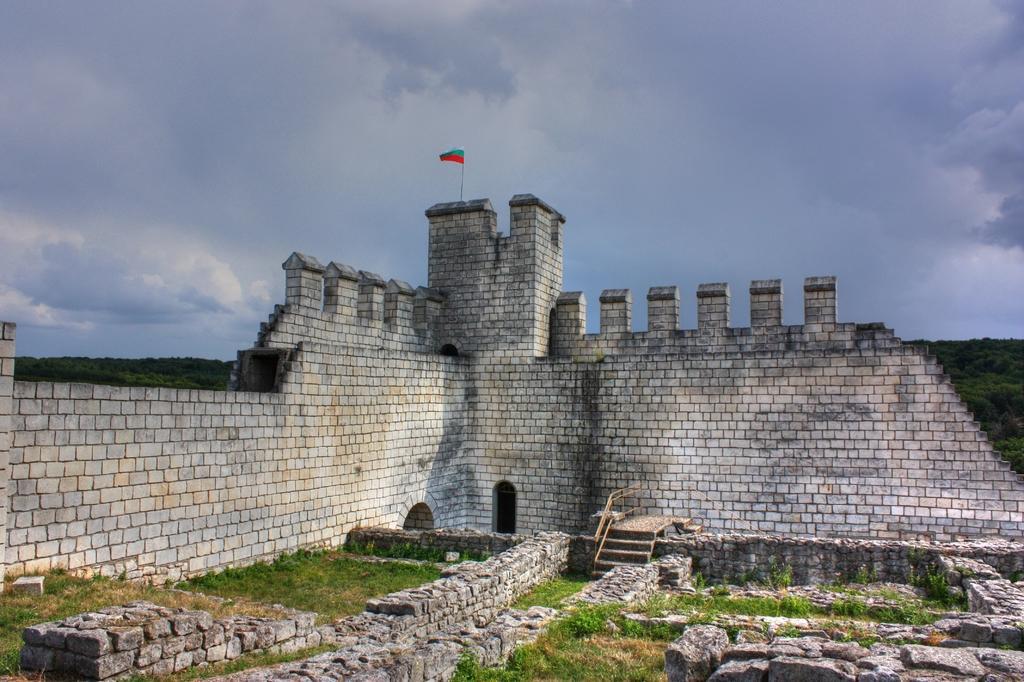Please provide a concise description of this image. In this image there is a wall having a flag on it. Behind it there is a hill having few trees on it. Bottom of image there are few stone walls on the grassland. There is a staircase to the wall. Top of image there is sky with some clouds. 